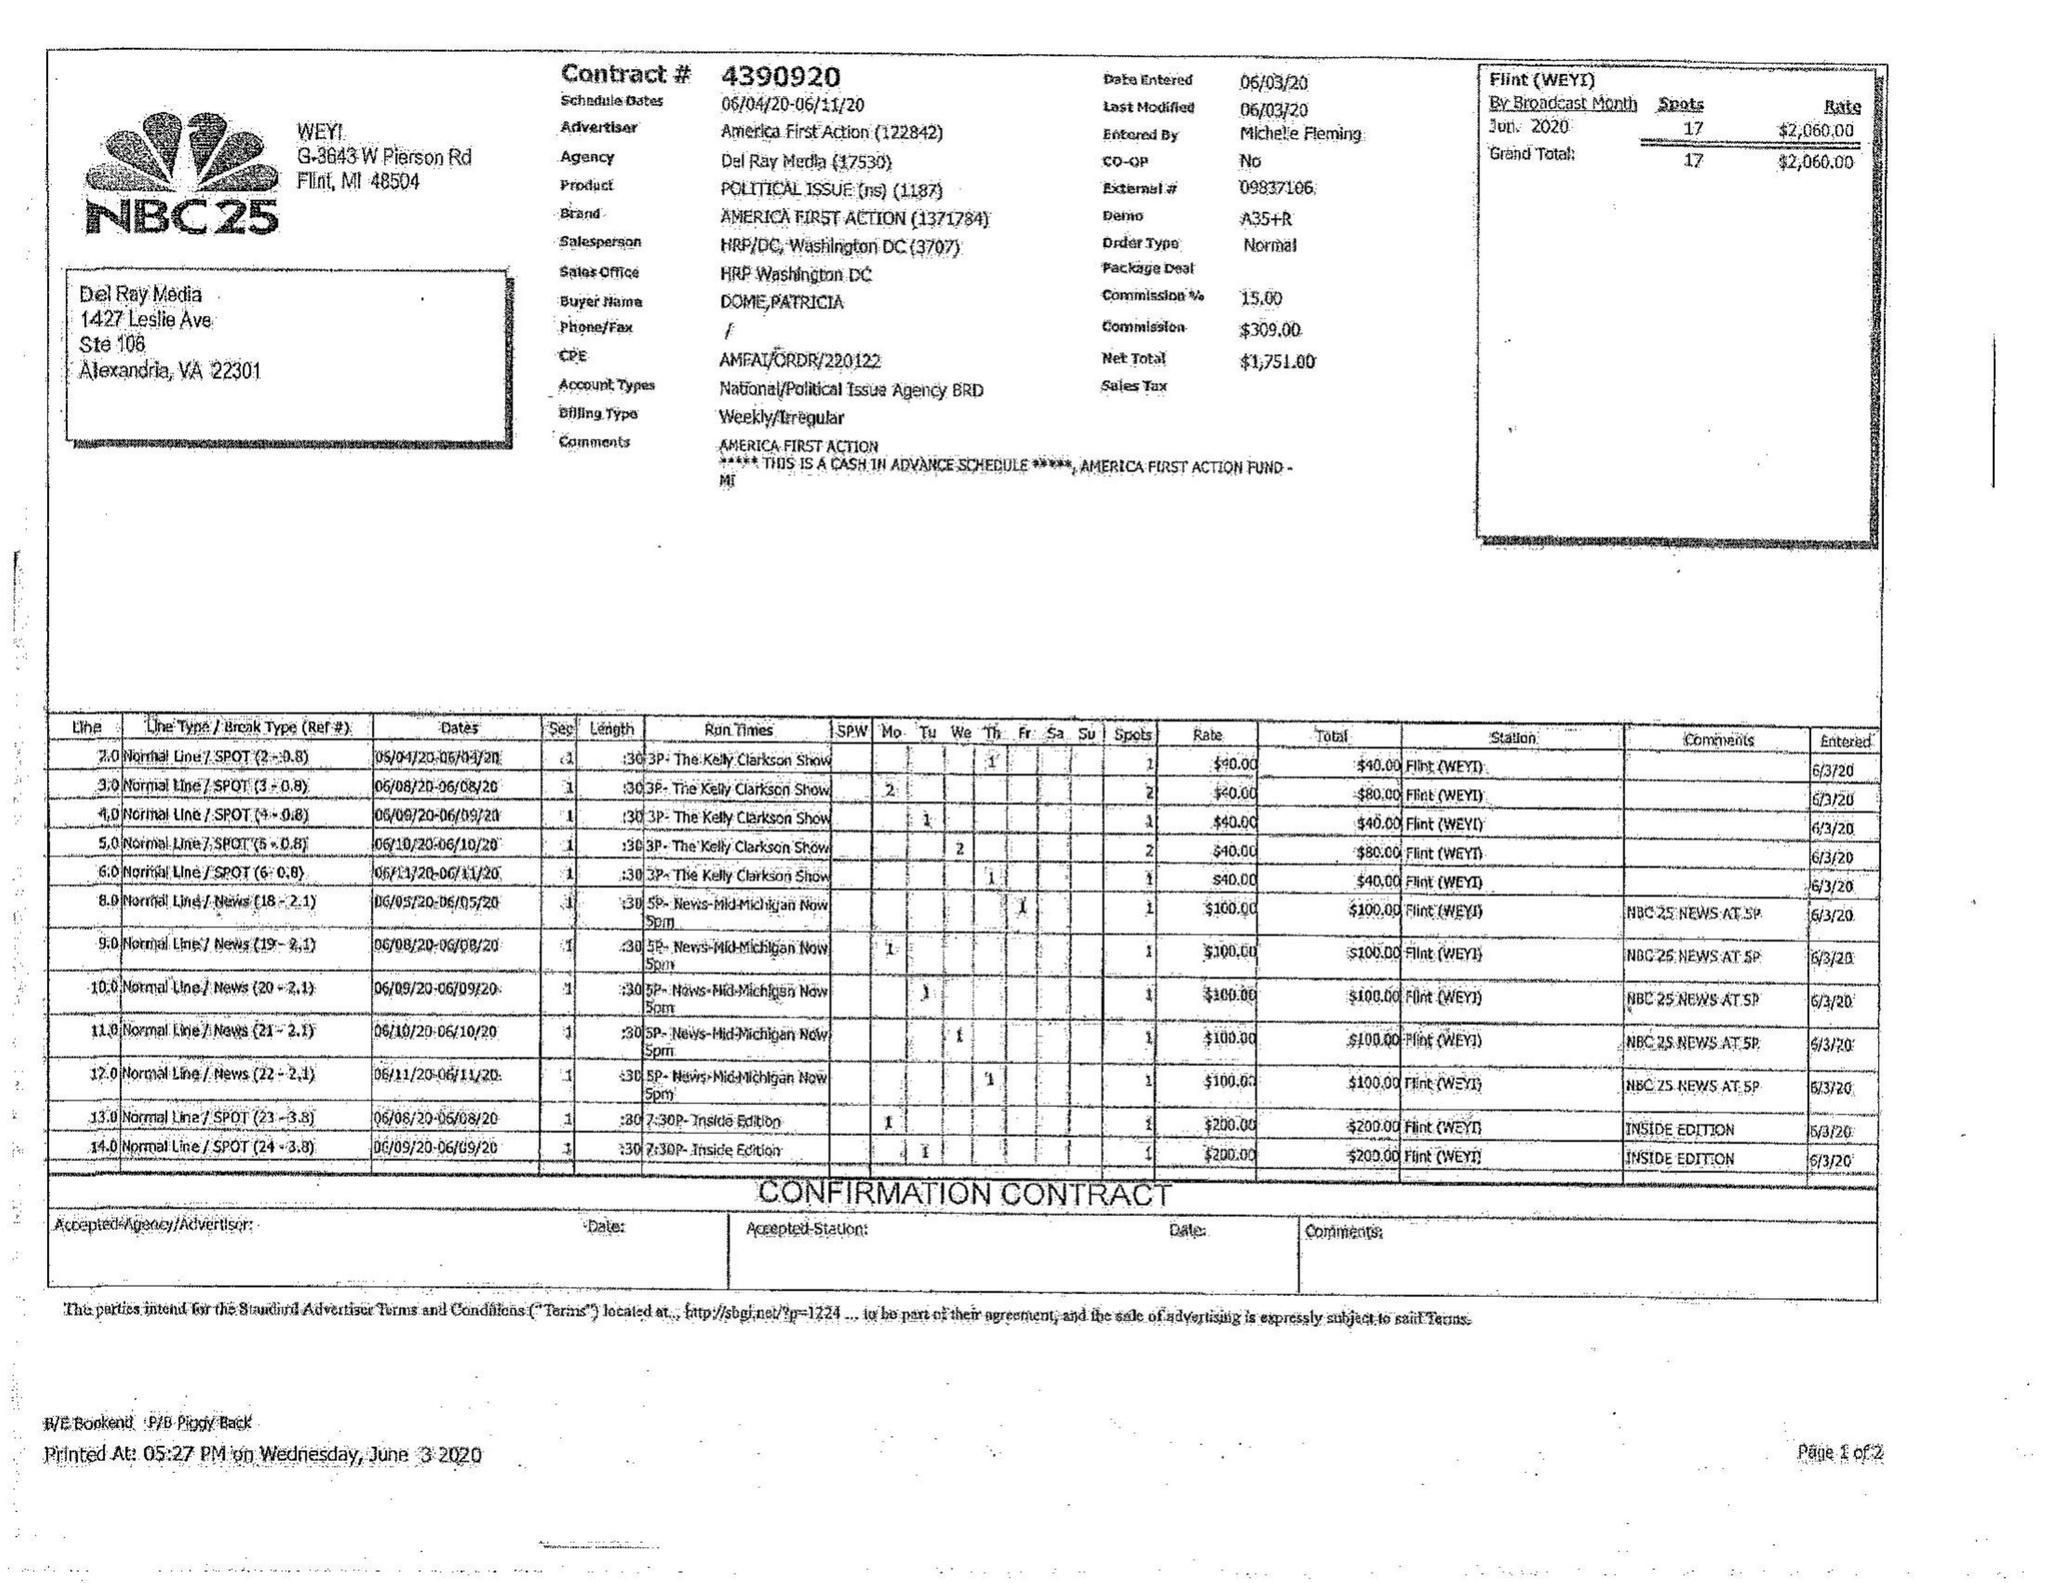What is the value for the advertiser?
Answer the question using a single word or phrase. ANIEIIEA FIRST ACTION 